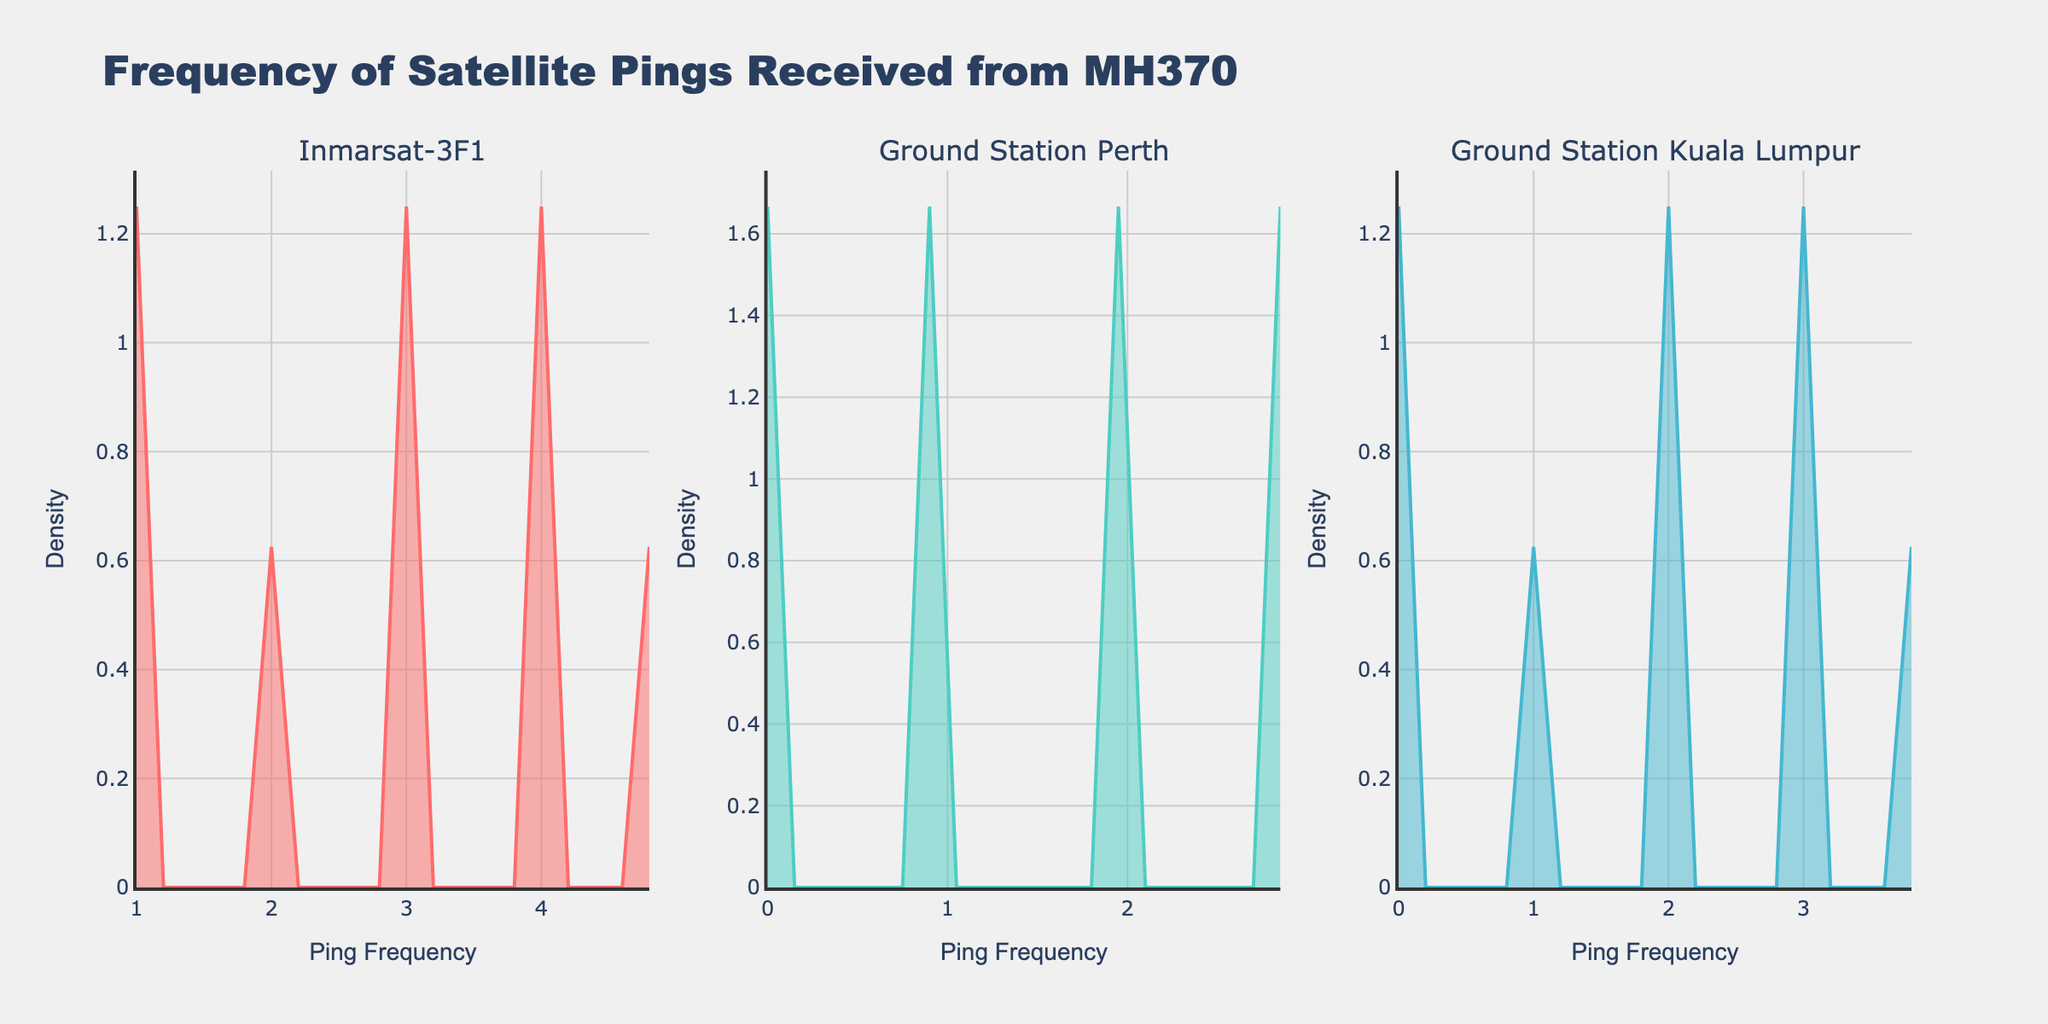What is the title of the figure? The title is typically located at the top of the figure and clearly states what the figure is about. In this case, it reads "Frequency of Satellite Pings Received from MH370".
Answer: Frequency of Satellite Pings Received from MH370 What are the labels on the x-axes? The labels on the x-axis are often present below the ticks on these axes. Here, all the subplots have the same x-axis label "Ping Frequency".
Answer: Ping Frequency What does the color of the line in each subplot represent? Each subplot has a different line color indicating different satellites or ground stations. In the first subplot, the line is red for Inmarsat-3F1, in the second subplot, the line is turquoise for Ground Station Perth, and in the third subplot, the line is blue for Ground Station Kuala Lumpur.
Answer: Different satellites or ground stations How many subplots are there in the figure? By visually counting the individual plots within the figure, we can see that there are three.
Answer: 3 Which satellite or ground station had the highest density peak? By observing the highest points of the density curves in each subplot, we notice that the red line (Inmarsat-3F1) reaches the highest peak.
Answer: Inmarsat-3F1 Are the density peaks higher or lower over time for Ground Station Kuala Lumpur? To determine this, we observe the progression of the peak heights specifically in the subplot labeled "Ground Station Kuala Lumpur". From left to right, the peak density appears to decrease.
Answer: Lower over time Compare the density peaks of Inmarsat-3F1 and Ground Station Perth. Which is higher? By looking at the subplots for Inmarsat-3F1 with the red line and Ground Station Perth with the turquoise line, we observe that the peak density for Inmarsat-3F1 is higher than that of Ground Station Perth.
Answer: Inmarsat-3F1 What happens to the density peaks as the ping frequency decreases? By observing the trends in all three subplots, we can see that the density peaks tend to decrease as the ping frequency goes lower.
Answer: Decrease What is the y-axis label for all the plots? The y-axis label on all the plots, typically located on the left side of the figure, reads "Density".
Answer: Density Are the density plots filled to the x-axis in each subplot? Observing the fill area under each curve in all three subplots, we see that the area under the curves is shaded, confirming that the density plots are filled to the x-axis.
Answer: Yes 